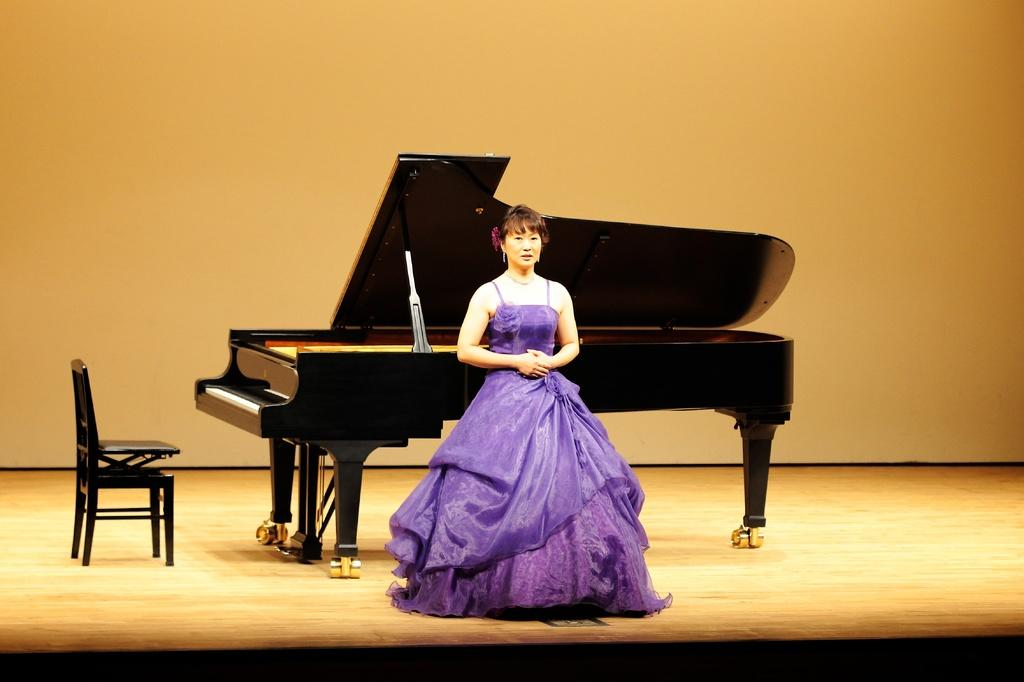What is the main subject of the image? There is a woman standing in the middle of the image. What can be seen in the background of the image? There is a piano in the background of the image. Where is the chair located in relation to the piano? There is a chair on the left side of the piano. What shape is the screw that the woman is holding in the image? There is no screw visible in the image; the woman is not holding any object. 